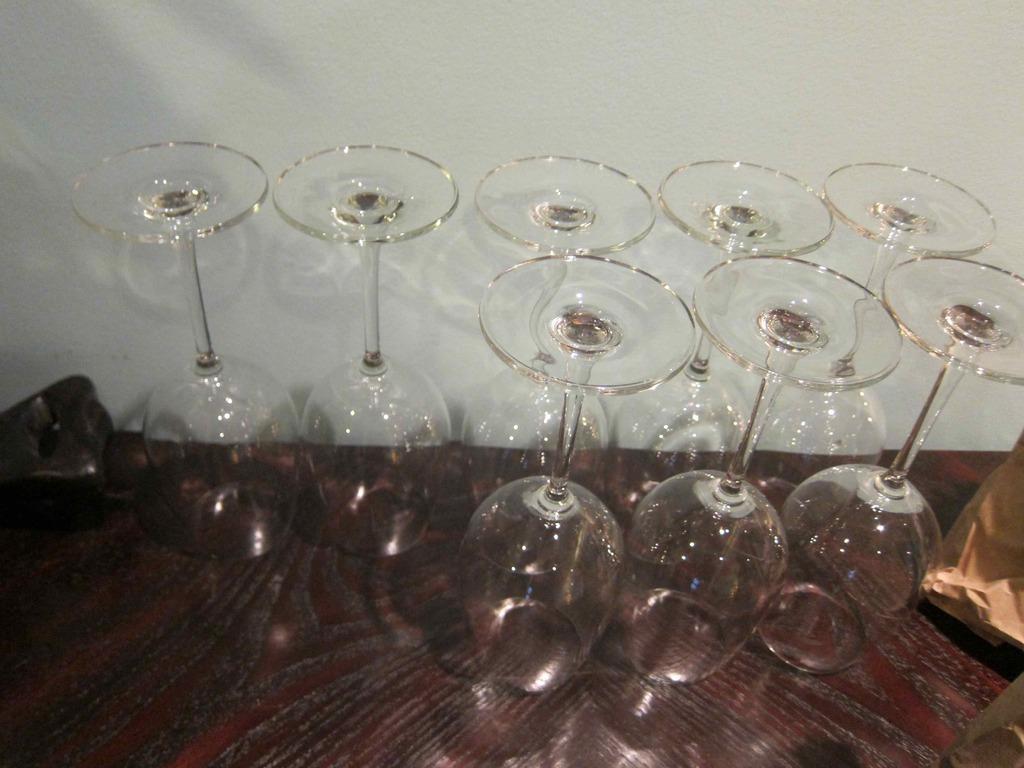How would you summarize this image in a sentence or two? In the picture we can see glasses on a wooden platform. In the background there is a wall. 